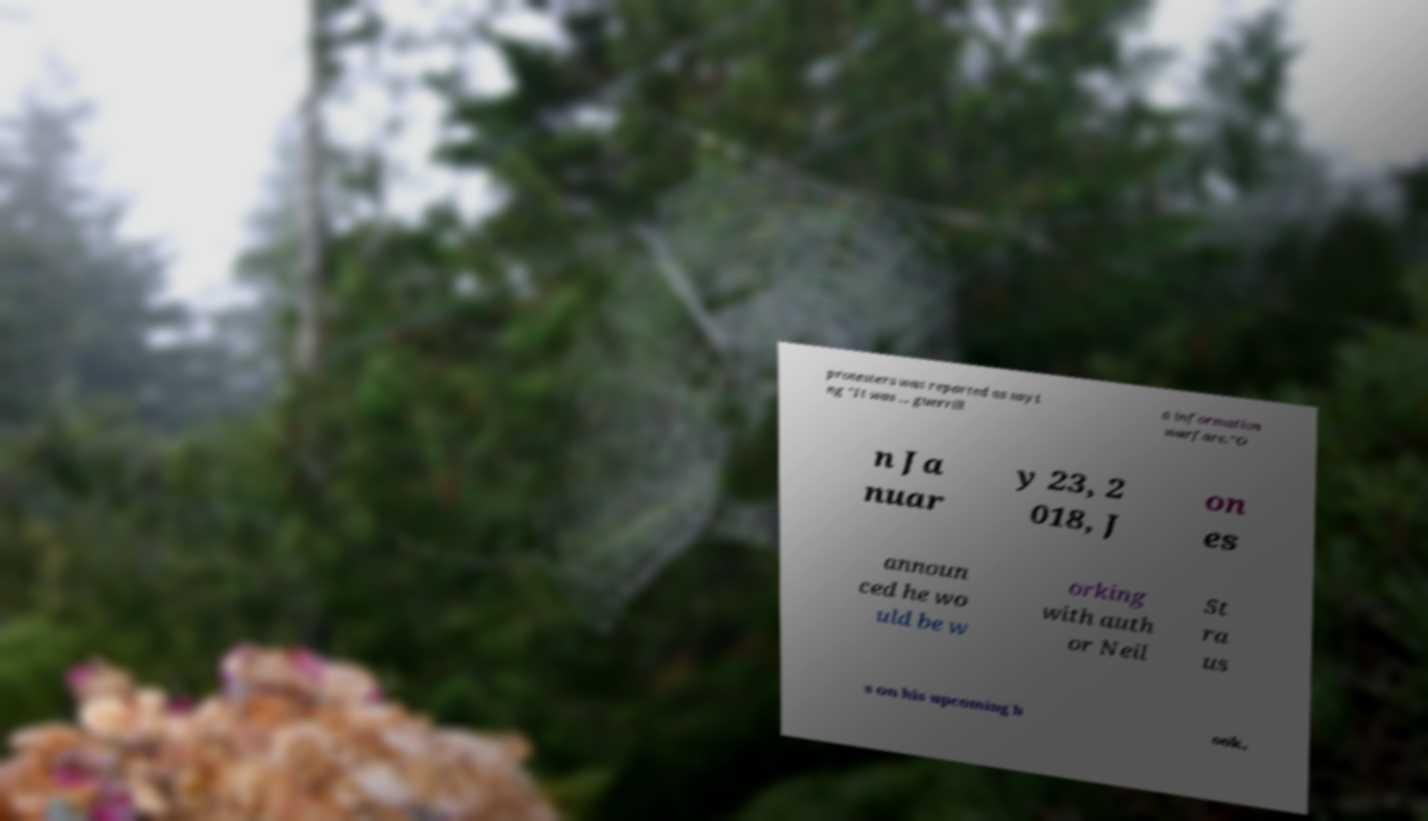What messages or text are displayed in this image? I need them in a readable, typed format. protesters was reported as sayi ng "It was ... guerrill a information warfare."O n Ja nuar y 23, 2 018, J on es announ ced he wo uld be w orking with auth or Neil St ra us s on his upcoming b ook, 